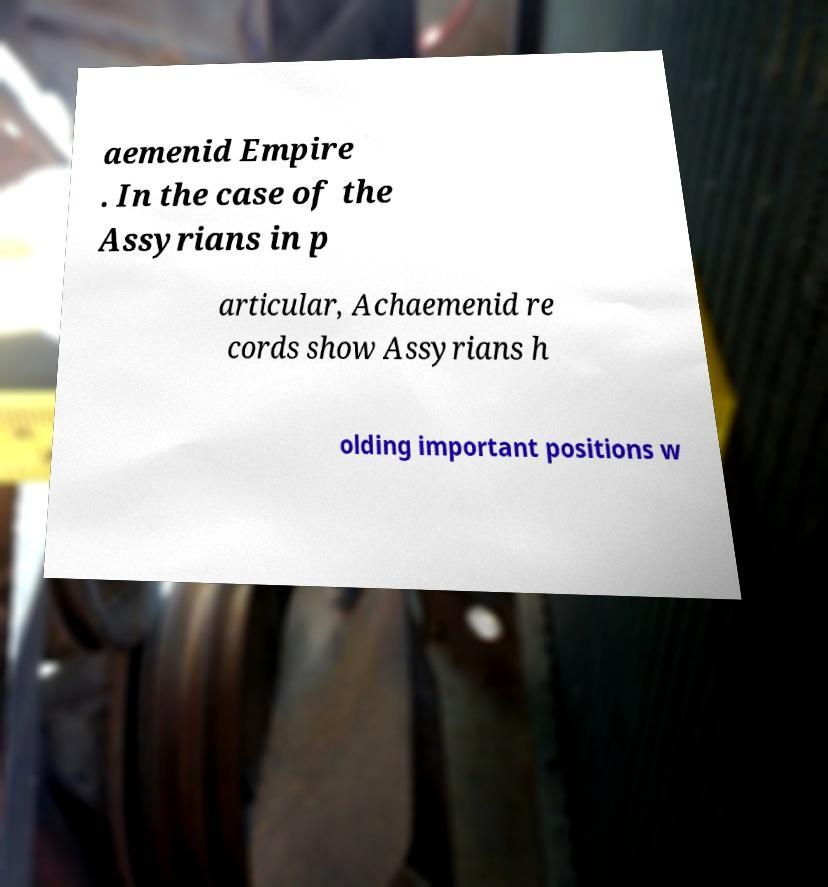Please read and relay the text visible in this image. What does it say? aemenid Empire . In the case of the Assyrians in p articular, Achaemenid re cords show Assyrians h olding important positions w 